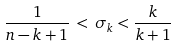Convert formula to latex. <formula><loc_0><loc_0><loc_500><loc_500>\frac { 1 } { n - k + 1 } \, < \, \sigma _ { k } < \frac { k } { k + 1 } \,</formula> 